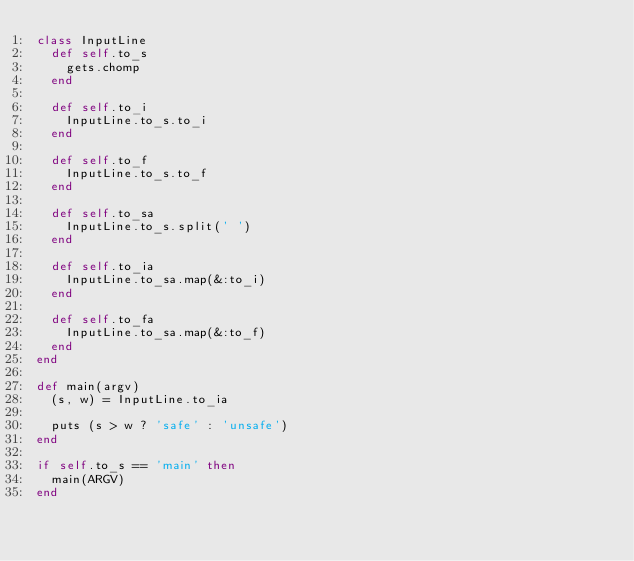Convert code to text. <code><loc_0><loc_0><loc_500><loc_500><_Ruby_>class InputLine
  def self.to_s
    gets.chomp
  end

  def self.to_i
    InputLine.to_s.to_i
  end
  
  def self.to_f
    InputLine.to_s.to_f
  end

  def self.to_sa
    InputLine.to_s.split(' ')
  end

  def self.to_ia
    InputLine.to_sa.map(&:to_i)
  end
  
  def self.to_fa
    InputLine.to_sa.map(&:to_f)
  end
end

def main(argv)
  (s, w) = InputLine.to_ia

  puts (s > w ? 'safe' : 'unsafe')
end

if self.to_s == 'main' then
  main(ARGV)
end</code> 